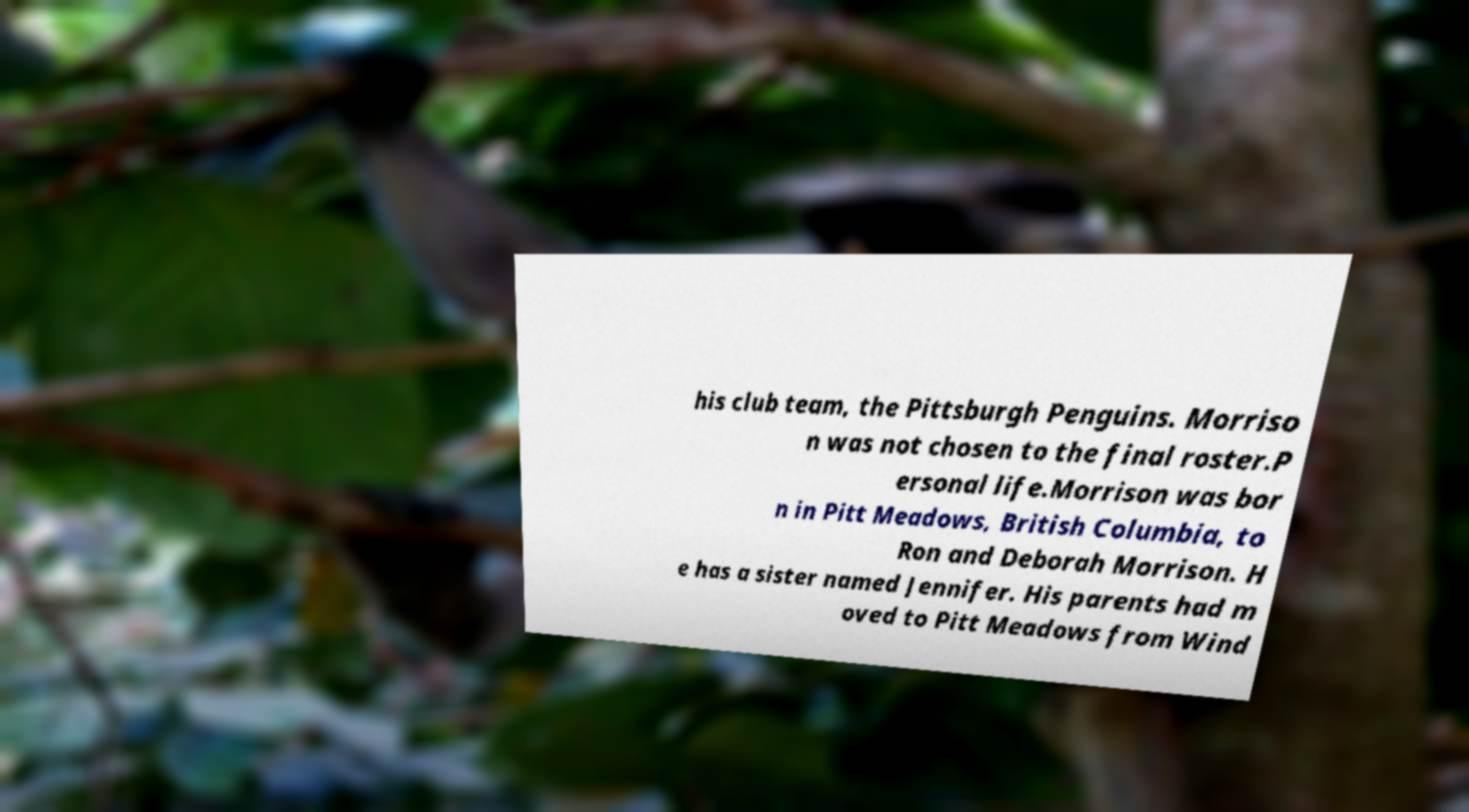Please read and relay the text visible in this image. What does it say? his club team, the Pittsburgh Penguins. Morriso n was not chosen to the final roster.P ersonal life.Morrison was bor n in Pitt Meadows, British Columbia, to Ron and Deborah Morrison. H e has a sister named Jennifer. His parents had m oved to Pitt Meadows from Wind 